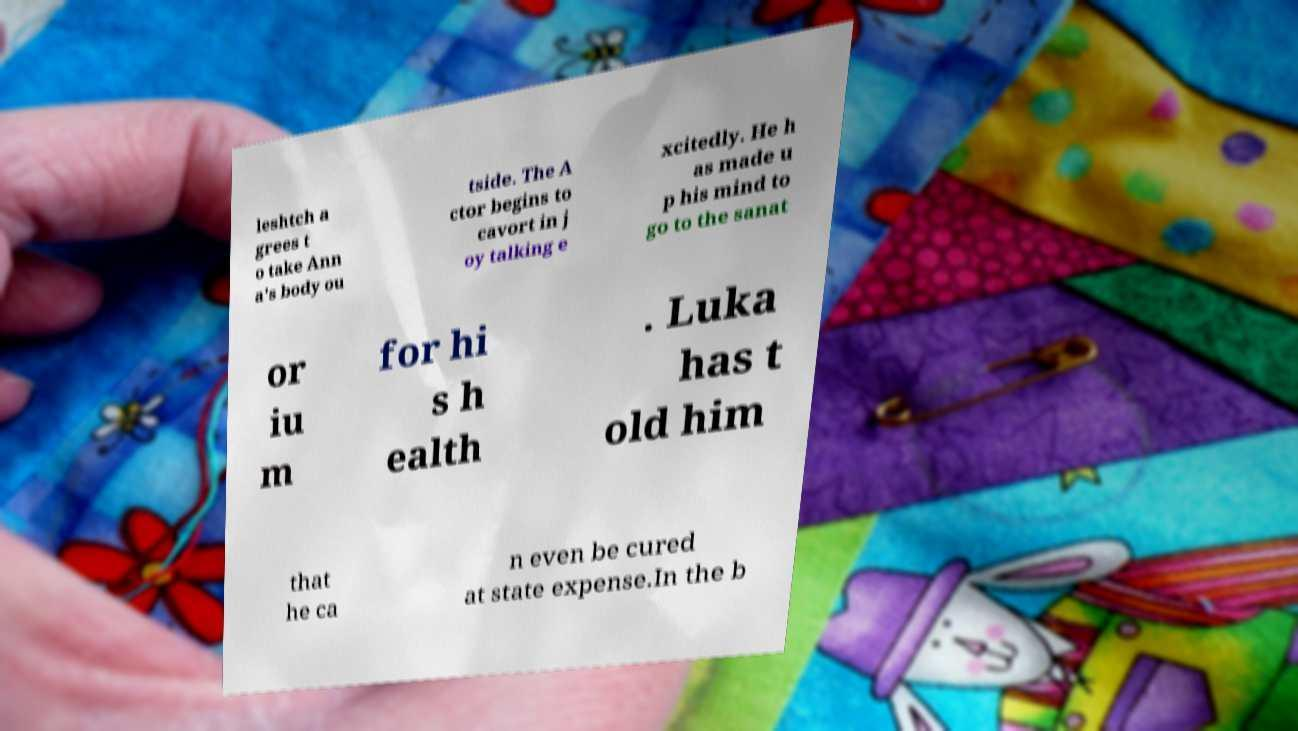Please identify and transcribe the text found in this image. leshtch a grees t o take Ann a's body ou tside. The A ctor begins to cavort in j oy talking e xcitedly. He h as made u p his mind to go to the sanat or iu m for hi s h ealth . Luka has t old him that he ca n even be cured at state expense.In the b 